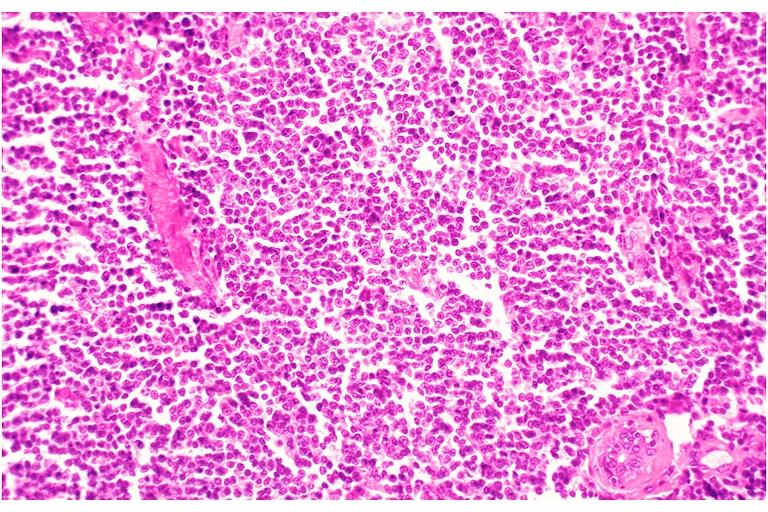does infiltrative process show leukemic infiltrate?
Answer the question using a single word or phrase. No 